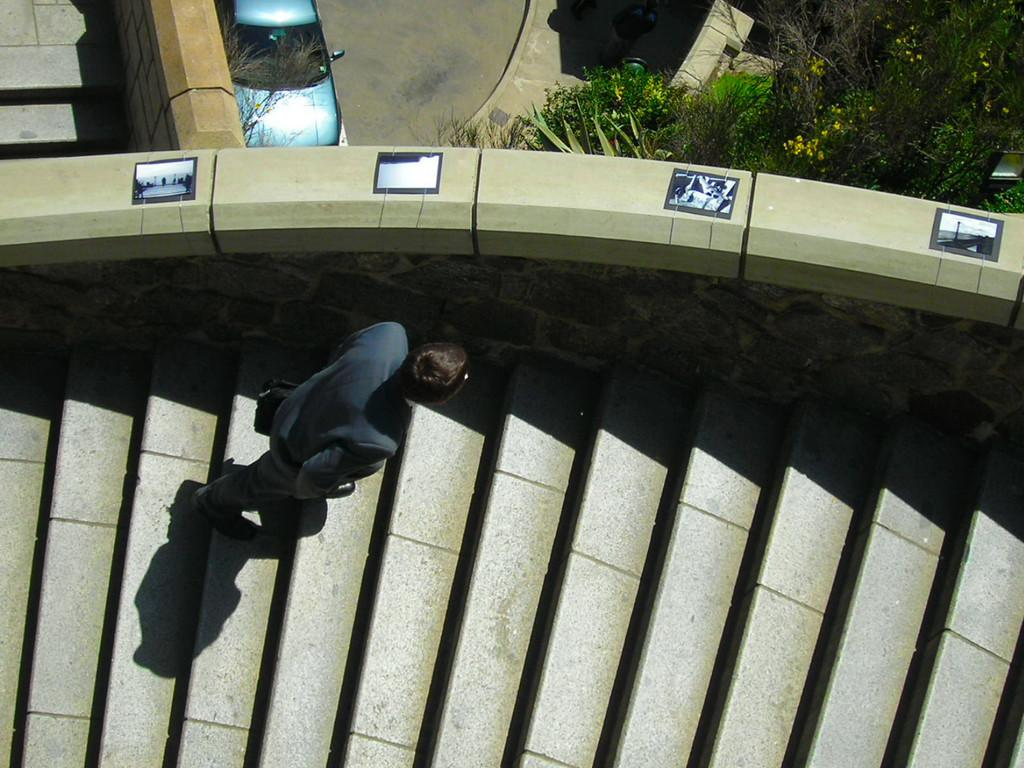What is the person in the image wearing? The person in the image is wearing a suit. What is the person doing in the image? The person is walking on steps. What can be seen on the road in the image? There is a car on the road in the image. What is visible in front of the car? Trees are visible in front of the car. Where is the rabbit hiding in the image? There is no rabbit present in the image. What type of vase can be seen on the steps with the person? There is no vase visible in the image; only the person in a suit and the steps are present. 